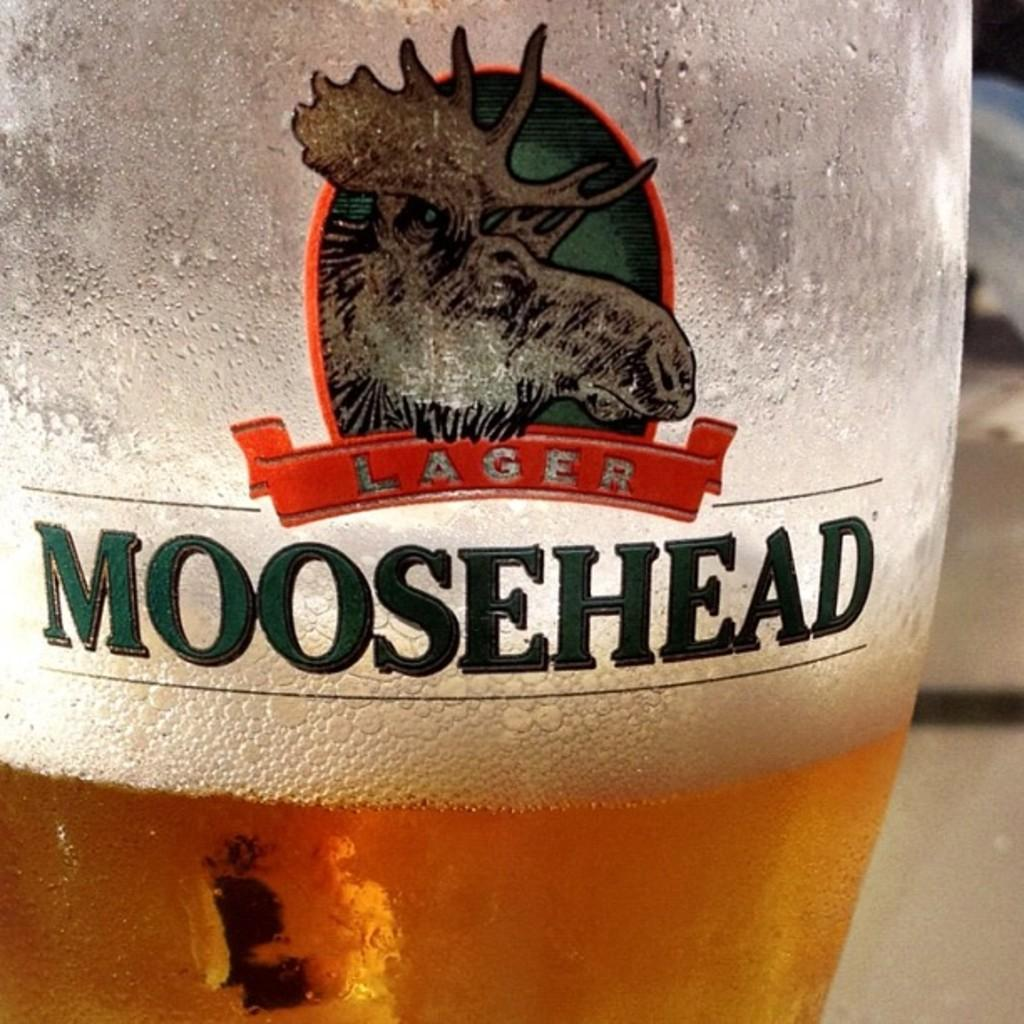What is on the bottle in the image? There is a logo on a bottle in the image. What is inside the bottle? The bottle contains a drink. What type of record is spinning on the table in the image? There is no record present in the image; it only features a bottle with a logo and a drink inside. How many marbles are visible on the floor in the image? There are no marbles visible in the image; it only features a bottle with a logo and a drink inside. 